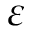Convert formula to latex. <formula><loc_0><loc_0><loc_500><loc_500>\varepsilon</formula> 